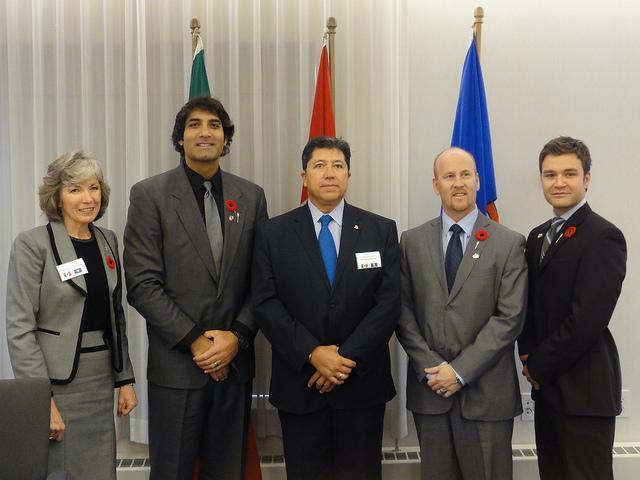How many men are in the picture?
Give a very brief answer. 4. How many flags appear?
Give a very brief answer. 3. How many people are in the photo?
Give a very brief answer. 5. 